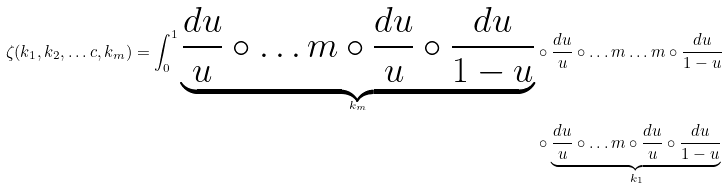<formula> <loc_0><loc_0><loc_500><loc_500>\zeta ( k _ { 1 } , k _ { 2 } , \dots c , k _ { m } ) = \int _ { 0 } ^ { 1 } \underbrace { \frac { d u } { u } \circ \dots m \circ \frac { d u } { u } \circ \frac { d u } { 1 - u } } _ { k _ { m } } & \circ \frac { d u } { u } \circ \dots m \dots m \circ \frac { d u } { 1 - u } \\ & \circ \underbrace { \frac { d u } { u } \circ \dots m \circ \frac { d u } { u } \circ \frac { d u } { 1 - u } } _ { k _ { 1 } }</formula> 